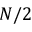<formula> <loc_0><loc_0><loc_500><loc_500>N / 2</formula> 